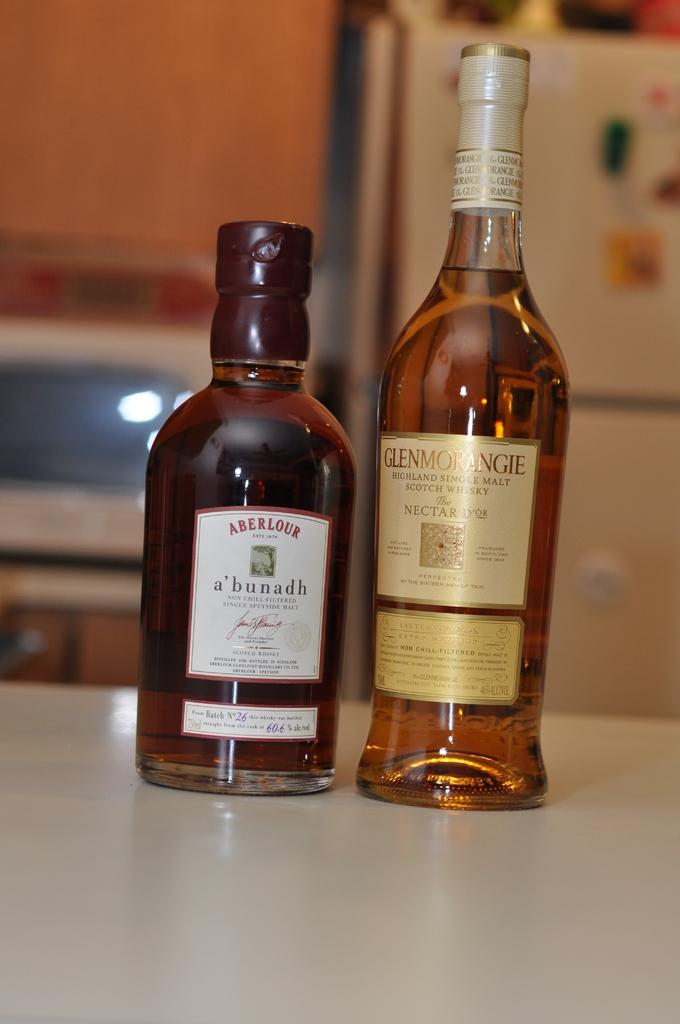<image>
Share a concise interpretation of the image provided. A bottle of Aberlour alcohol and a bottle of Glenmorangie alcohol. 